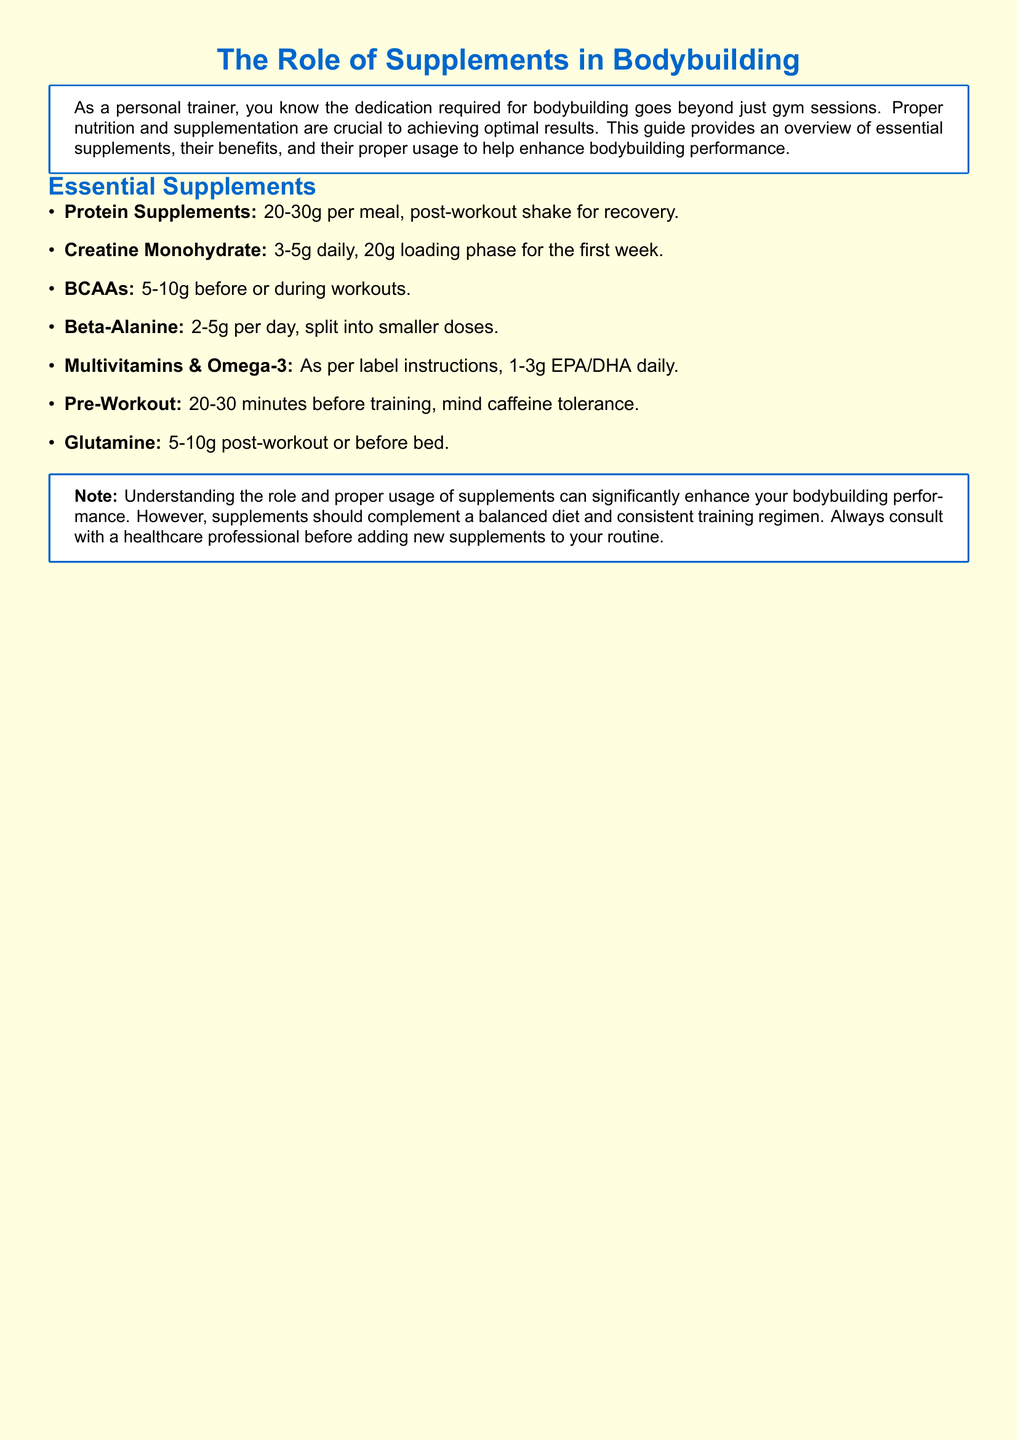What is the recommended daily intake of Creatine Monohydrate? The document specifies a daily intake of 3-5g, with a loading phase of 20g for the first week.
Answer: 3-5g How much Protein Supplement should be consumed per meal? It is indicated that 20-30g of protein should be consumed per meal.
Answer: 20-30g When should BCAAs be taken? The guide notes that BCAAs should be taken before or during workouts.
Answer: Before or during workouts What is the recommended dosage for Beta-Alanine? The document states a dosage of 2-5g per day, split into smaller doses.
Answer: 2-5g What is the minimum time before training to take Pre-Workout? The guide suggests taking Pre-Workout 20-30 minutes before training.
Answer: 20-30 minutes Why should supplements be used? The document mentions that supplements can significantly enhance bodybuilding performance.
Answer: To enhance bodybuilding performance What should supplements complement according to the note? It is advised that supplements should complement a balanced diet and consistent training regimen.
Answer: A balanced diet and consistent training regimen What is a crucial step before adding new supplements? The guide recommends consulting with a healthcare professional before adding new supplements to the routine.
Answer: Consult with a healthcare professional 